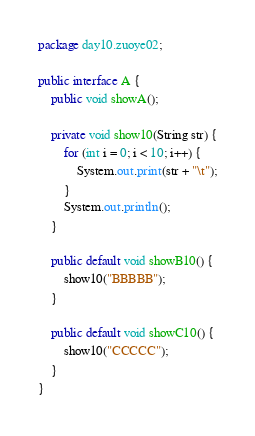Convert code to text. <code><loc_0><loc_0><loc_500><loc_500><_Java_>package day10.zuoye02;

public interface A {
    public void showA();

    private void show10(String str) {
        for (int i = 0; i < 10; i++) {
            System.out.print(str + "\t");
        }
        System.out.println();
    }

    public default void showB10() {
        show10("BBBBB");
    }

    public default void showC10() {
        show10("CCCCC");
    }
}
</code> 